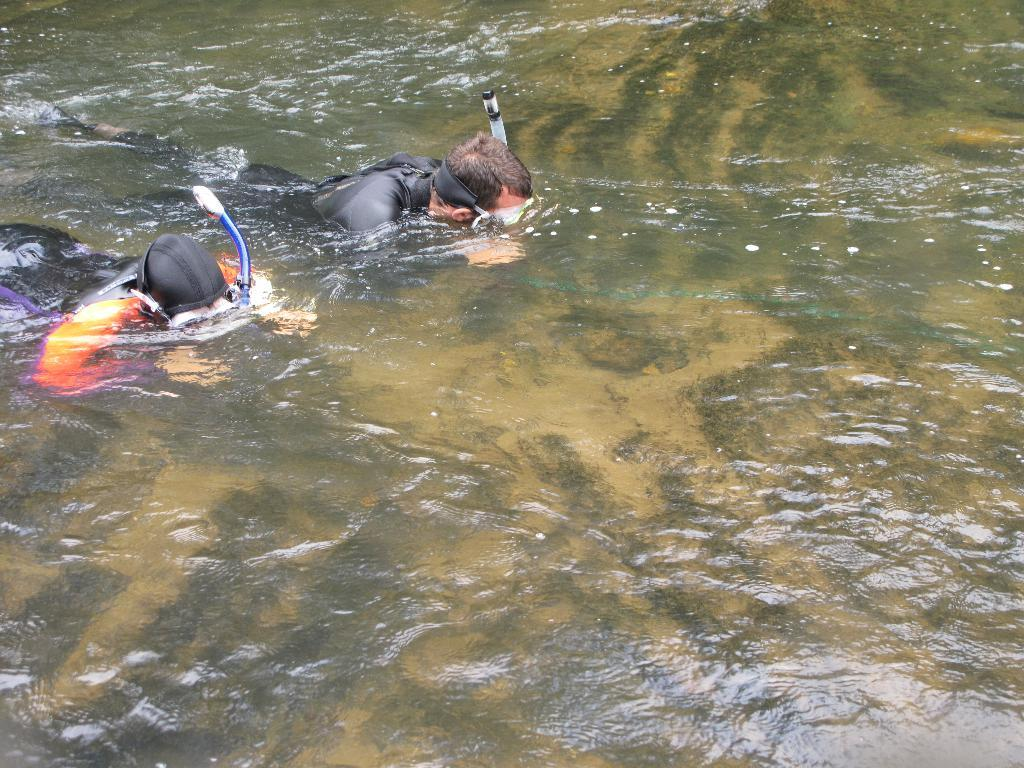How many people are in the image? There are two persons in the image. What are the persons doing in the image? The persons are swimming in the water. What type of clothing are the persons wearing? The persons are wearing swimsuits. What is the primary element visible in the image? There is water visible in the image. What type of noise can be heard coming from the books in the image? There are no books present in the image, so it's not possible to determine what noise might be coming from them. 